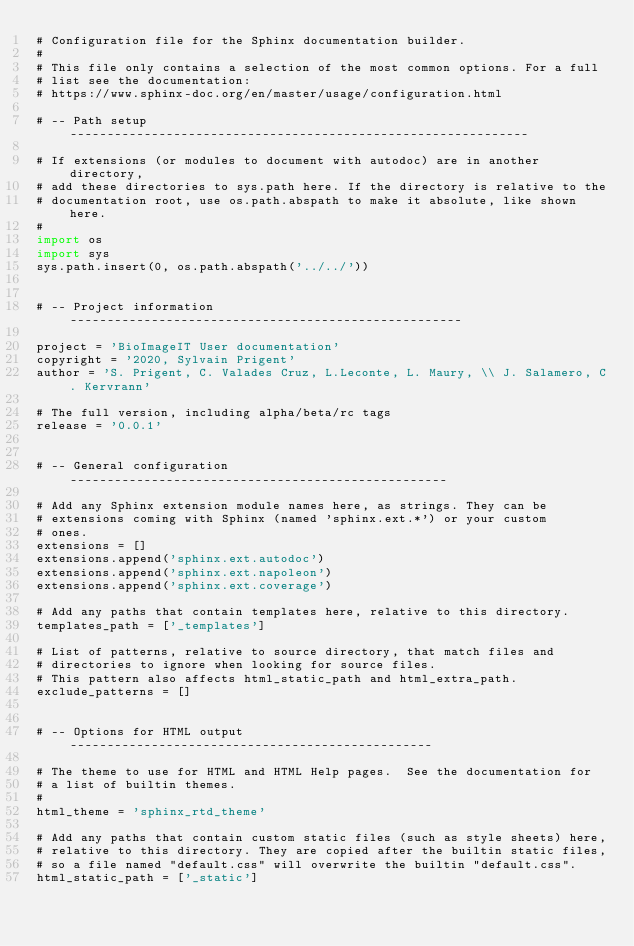Convert code to text. <code><loc_0><loc_0><loc_500><loc_500><_Python_># Configuration file for the Sphinx documentation builder.
#
# This file only contains a selection of the most common options. For a full
# list see the documentation:
# https://www.sphinx-doc.org/en/master/usage/configuration.html

# -- Path setup --------------------------------------------------------------

# If extensions (or modules to document with autodoc) are in another directory,
# add these directories to sys.path here. If the directory is relative to the
# documentation root, use os.path.abspath to make it absolute, like shown here.
#
import os
import sys
sys.path.insert(0, os.path.abspath('../../'))


# -- Project information -----------------------------------------------------

project = 'BioImageIT User documentation'
copyright = '2020, Sylvain Prigent'
author = 'S. Prigent, C. Valades Cruz, L.Leconte, L. Maury, \\ J. Salamero, C. Kervrann'

# The full version, including alpha/beta/rc tags
release = '0.0.1'


# -- General configuration ---------------------------------------------------

# Add any Sphinx extension module names here, as strings. They can be
# extensions coming with Sphinx (named 'sphinx.ext.*') or your custom
# ones.
extensions = []
extensions.append('sphinx.ext.autodoc')
extensions.append('sphinx.ext.napoleon')
extensions.append('sphinx.ext.coverage')

# Add any paths that contain templates here, relative to this directory.
templates_path = ['_templates']

# List of patterns, relative to source directory, that match files and
# directories to ignore when looking for source files.
# This pattern also affects html_static_path and html_extra_path.
exclude_patterns = []


# -- Options for HTML output -------------------------------------------------

# The theme to use for HTML and HTML Help pages.  See the documentation for
# a list of builtin themes.
#
html_theme = 'sphinx_rtd_theme'

# Add any paths that contain custom static files (such as style sheets) here,
# relative to this directory. They are copied after the builtin static files,
# so a file named "default.css" will overwrite the builtin "default.css".
html_static_path = ['_static']</code> 